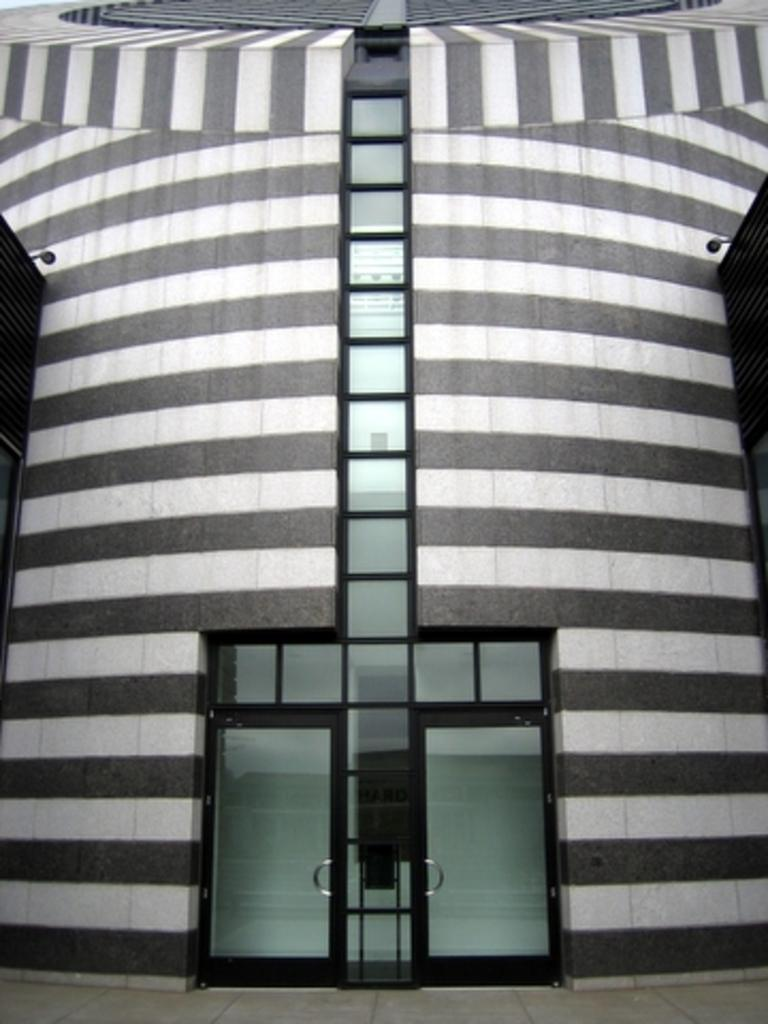What is the main structure in the center of the image? There is a building in the center of the image. What type of barrier can be seen in the image? There is a wall in the image. What material is used for the windows in the image? There is glass in the image. How can someone enter the building in the image? There is a door in the image. What color can be observed among the objects in the image? There are black color objects in the image. What type of wheel is used to transport the property in the image? There is no wheel or property present in the image. 